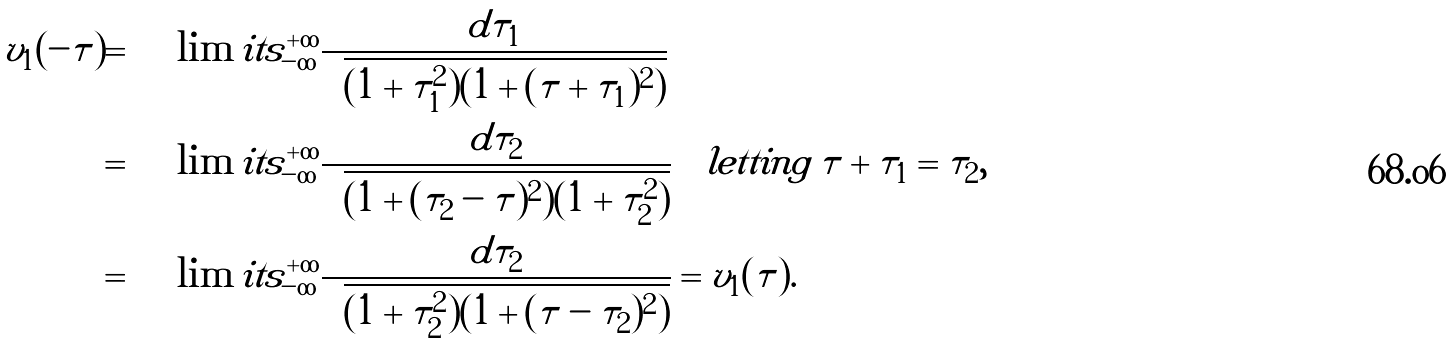<formula> <loc_0><loc_0><loc_500><loc_500>v _ { 1 } ( - \tau ) = & \int \lim i t s _ { - \infty } ^ { + \infty } \frac { d \tau _ { 1 } } { \sqrt { ( 1 + \tau _ { 1 } ^ { 2 } ) ( 1 + ( \tau + \tau _ { 1 } ) ^ { 2 } ) } } \\ = & \int \lim i t s _ { - \infty } ^ { + \infty } \frac { d \tau _ { 2 } } { \sqrt { ( 1 + ( \tau _ { 2 } - \tau ) ^ { 2 } ) ( 1 + \tau _ { 2 } ^ { 2 } ) } } \quad l e t t i n g \, \tau + \tau _ { 1 } = \tau _ { 2 } , \\ = & \int \lim i t s _ { - \infty } ^ { + \infty } \frac { d \tau _ { 2 } } { \sqrt { ( 1 + \tau _ { 2 } ^ { 2 } ) ( 1 + ( \tau - \tau _ { 2 } ) ^ { 2 } ) } } = v _ { 1 } ( \tau ) .</formula> 